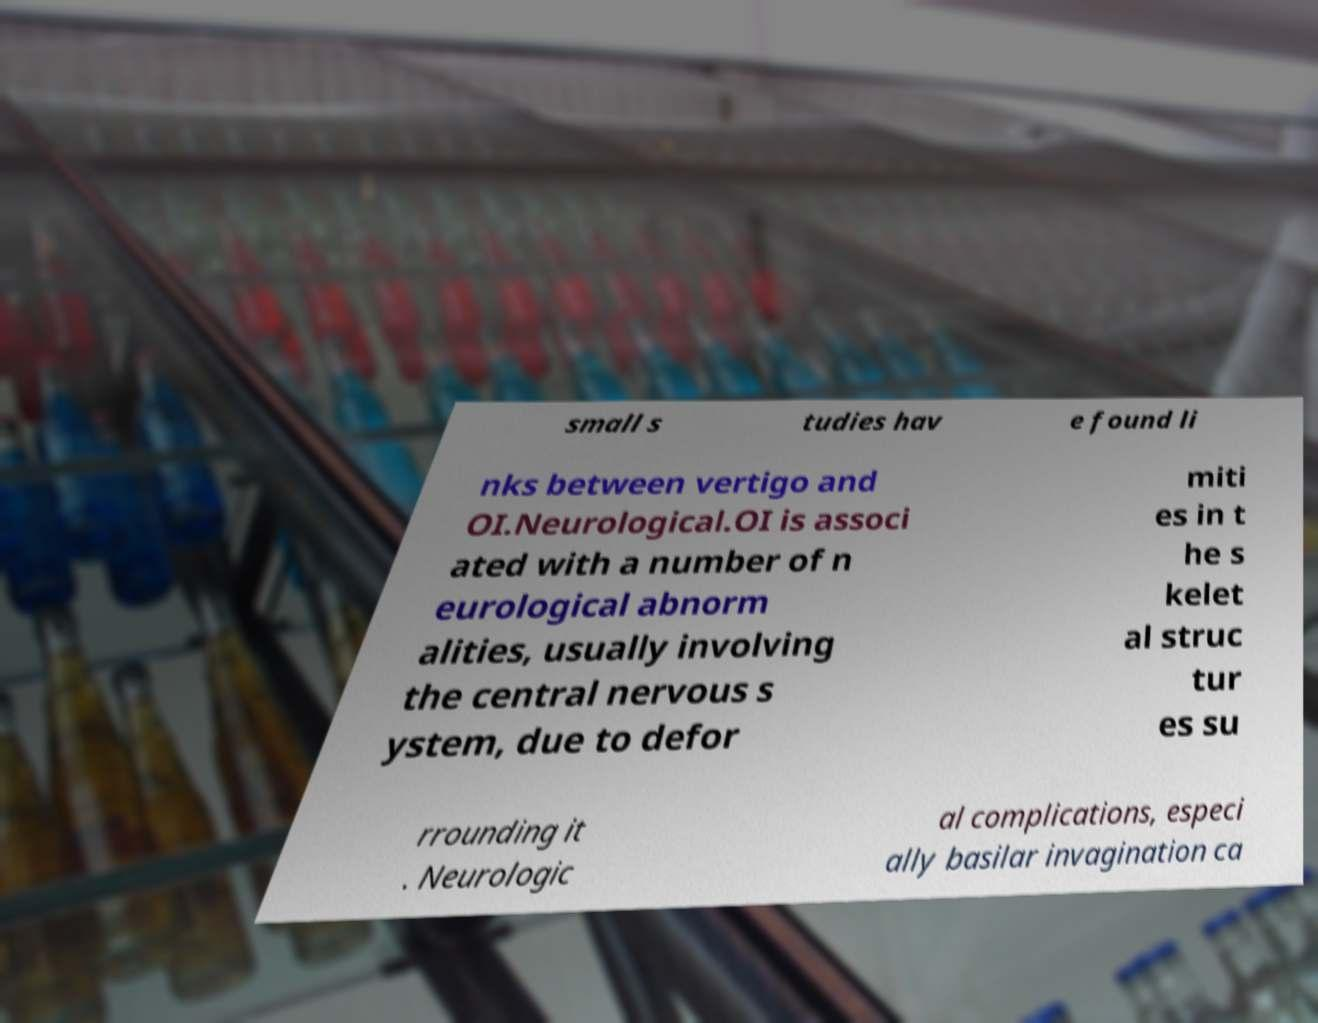What messages or text are displayed in this image? I need them in a readable, typed format. small s tudies hav e found li nks between vertigo and OI.Neurological.OI is associ ated with a number of n eurological abnorm alities, usually involving the central nervous s ystem, due to defor miti es in t he s kelet al struc tur es su rrounding it . Neurologic al complications, especi ally basilar invagination ca 